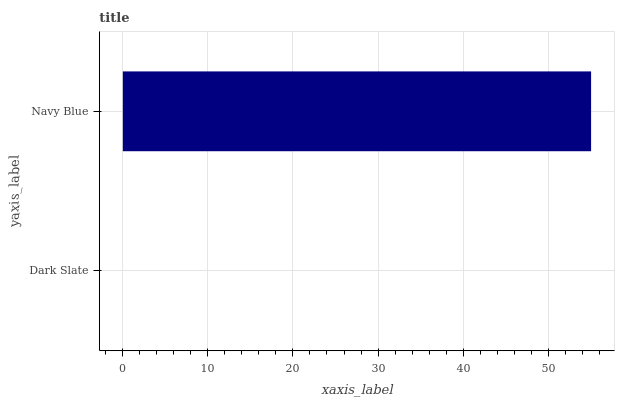Is Dark Slate the minimum?
Answer yes or no. Yes. Is Navy Blue the maximum?
Answer yes or no. Yes. Is Navy Blue the minimum?
Answer yes or no. No. Is Navy Blue greater than Dark Slate?
Answer yes or no. Yes. Is Dark Slate less than Navy Blue?
Answer yes or no. Yes. Is Dark Slate greater than Navy Blue?
Answer yes or no. No. Is Navy Blue less than Dark Slate?
Answer yes or no. No. Is Navy Blue the high median?
Answer yes or no. Yes. Is Dark Slate the low median?
Answer yes or no. Yes. Is Dark Slate the high median?
Answer yes or no. No. Is Navy Blue the low median?
Answer yes or no. No. 